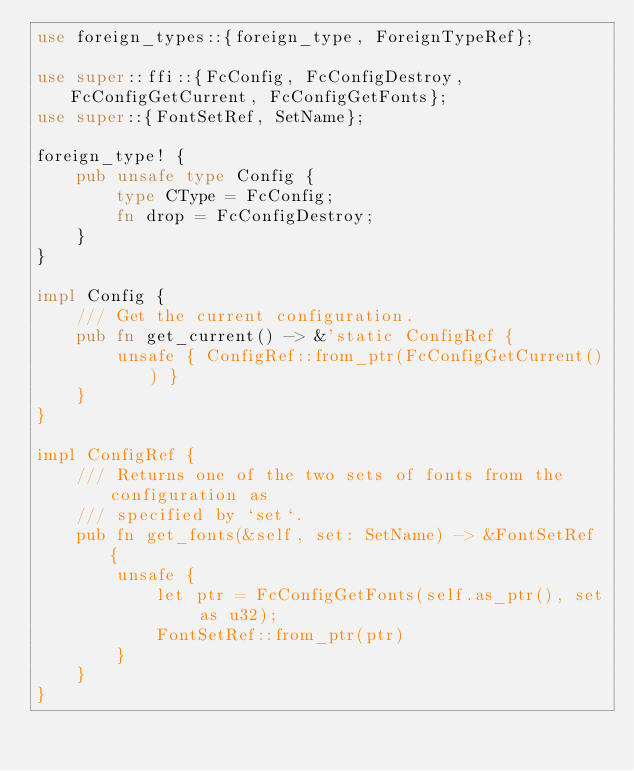Convert code to text. <code><loc_0><loc_0><loc_500><loc_500><_Rust_>use foreign_types::{foreign_type, ForeignTypeRef};

use super::ffi::{FcConfig, FcConfigDestroy, FcConfigGetCurrent, FcConfigGetFonts};
use super::{FontSetRef, SetName};

foreign_type! {
    pub unsafe type Config {
        type CType = FcConfig;
        fn drop = FcConfigDestroy;
    }
}

impl Config {
    /// Get the current configuration.
    pub fn get_current() -> &'static ConfigRef {
        unsafe { ConfigRef::from_ptr(FcConfigGetCurrent()) }
    }
}

impl ConfigRef {
    /// Returns one of the two sets of fonts from the configuration as
    /// specified by `set`.
    pub fn get_fonts(&self, set: SetName) -> &FontSetRef {
        unsafe {
            let ptr = FcConfigGetFonts(self.as_ptr(), set as u32);
            FontSetRef::from_ptr(ptr)
        }
    }
}
</code> 